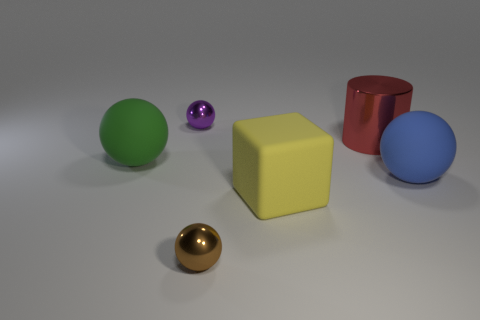How many other things are there of the same size as the yellow rubber cube? There are two objects that appear to be of similar size to the yellow rubber cube: the blue sphere and the red cylinder. 